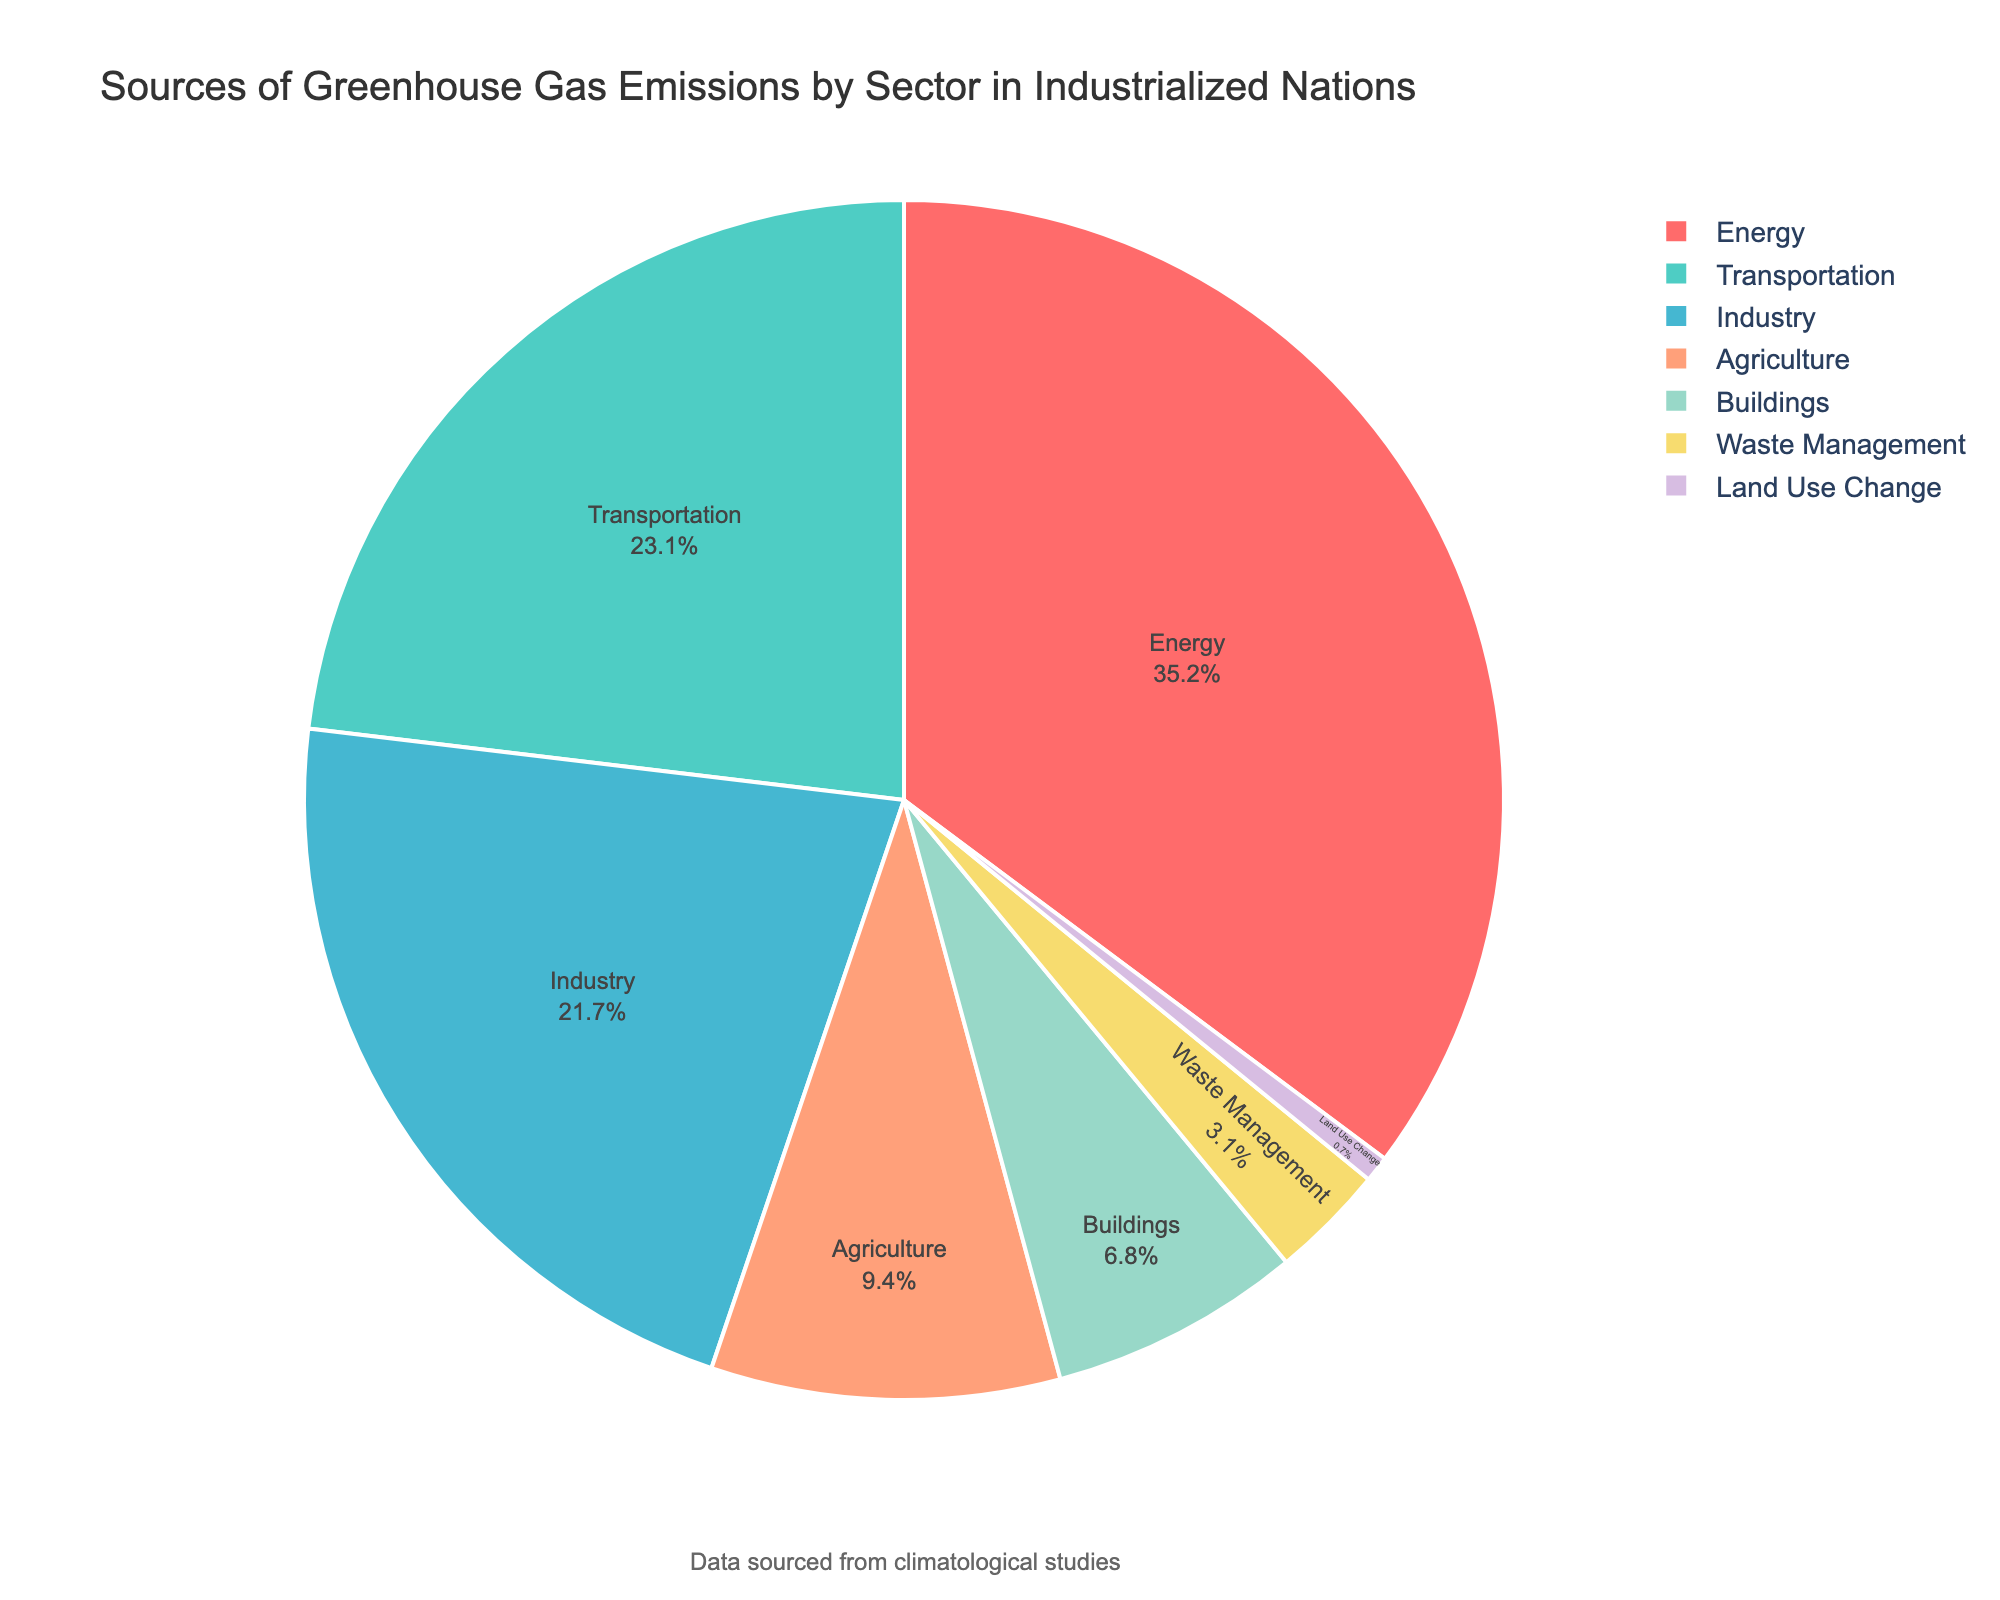Which sector contributes the most to greenhouse gas emissions? The pie chart clearly shows that the 'Energy' sector has the largest slice, meaning it has the highest percentage at 35.2%.
Answer: Energy Which two sectors combined contribute more than half of the total greenhouse gas emissions? Adding the percentages of the top two sectors: 'Energy' (35.2%) and 'Transportation' (23.1%) results in 58.3%, which is more than half (50%).
Answer: Energy and Transportation How much more does the 'Industry' sector contribute to emissions compared to the 'Buildings' sector? The 'Industry' sector contributes 21.7%, while 'Buildings' contribute 6.8%. Subtracting these two values: 21.7% - 6.8% = 14.9%.
Answer: 14.9% What is the percentage difference between the sector with the highest and the sector with the lowest emissions? The 'Energy' sector has the highest emissions at 35.2%, and 'Land Use Change' has the lowest at 0.7%. The difference is 35.2% - 0.7% = 34.5%.
Answer: 34.5% Which sectors contribute to less than 10% of greenhouse gas emissions individually? From the pie chart, 'Agriculture' (9.4%), 'Buildings' (6.8%), 'Waste Management' (3.1%), and 'Land Use Change' (0.7%) each contribute less than 10%.
Answer: Agriculture, Buildings, Waste Management, and Land Use Change What is the combined percentage of emissions from 'Agriculture', 'Buildings', 'Waste Management', and 'Land Use Change'? Summing up their percentages: 9.4% (Agriculture) + 6.8% (Buildings) + 3.1% (Waste Management) + 0.7% (Land Use Change) results in a total of 20%.
Answer: 20% Compare the contributions of the 'Transportation' and 'Industry' sectors. Which one emits more, and by how much? 'Transportation' emits 23.1%, while 'Industry' emits 21.7%. The difference is 23.1% - 21.7% = 1.4%. 'Transportation' emits 1.4% more than 'Industry'.
Answer: Transportation emits 1.4% more Is the 'Agriculture' sector closer in its emissions percentage to the 'Industry' or the 'Buildings' sector? 'Agriculture' is at 9.4%. The difference with 'Industry' (21.7%) is 21.7% - 9.4% = 12.3%. The difference with 'Buildings' (6.8%) is 9.4% - 6.8% = 2.6%. Therefore, 'Agriculture' is closer to 'Buildings'.
Answer: Buildings Which sector is represented by green color in the pie chart? By referring to the custom color palette sequence used in the chart, the 'Transportation' sector is depicted in green color.
Answer: Transportation 